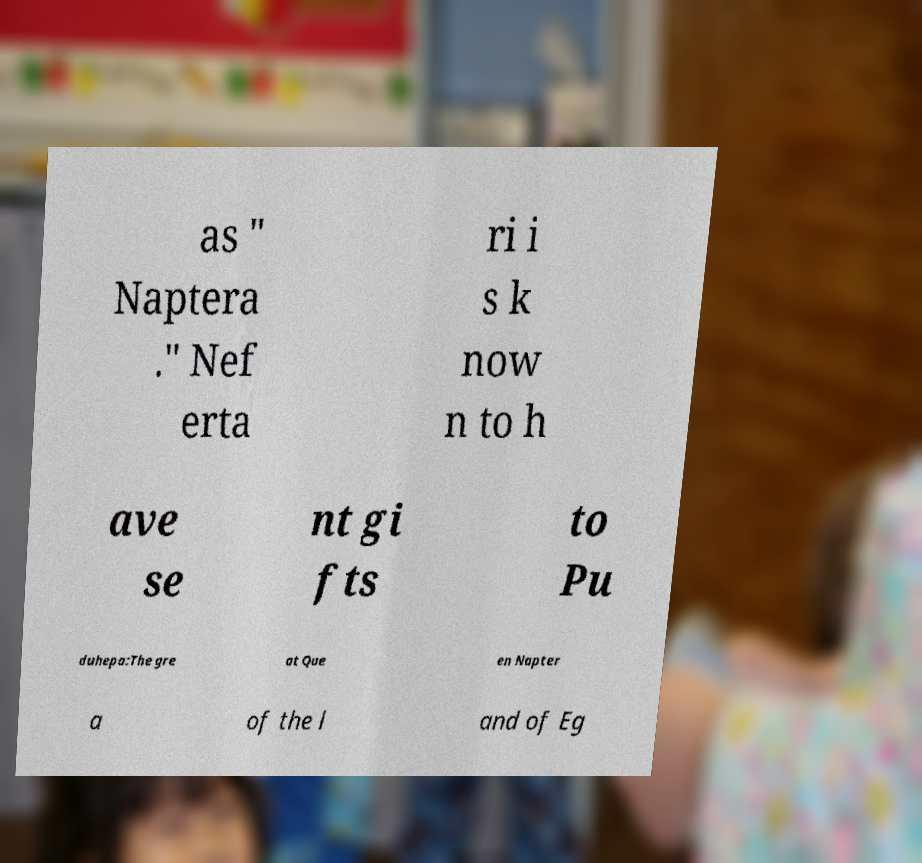Can you accurately transcribe the text from the provided image for me? as " Naptera ." Nef erta ri i s k now n to h ave se nt gi fts to Pu duhepa:The gre at Que en Napter a of the l and of Eg 